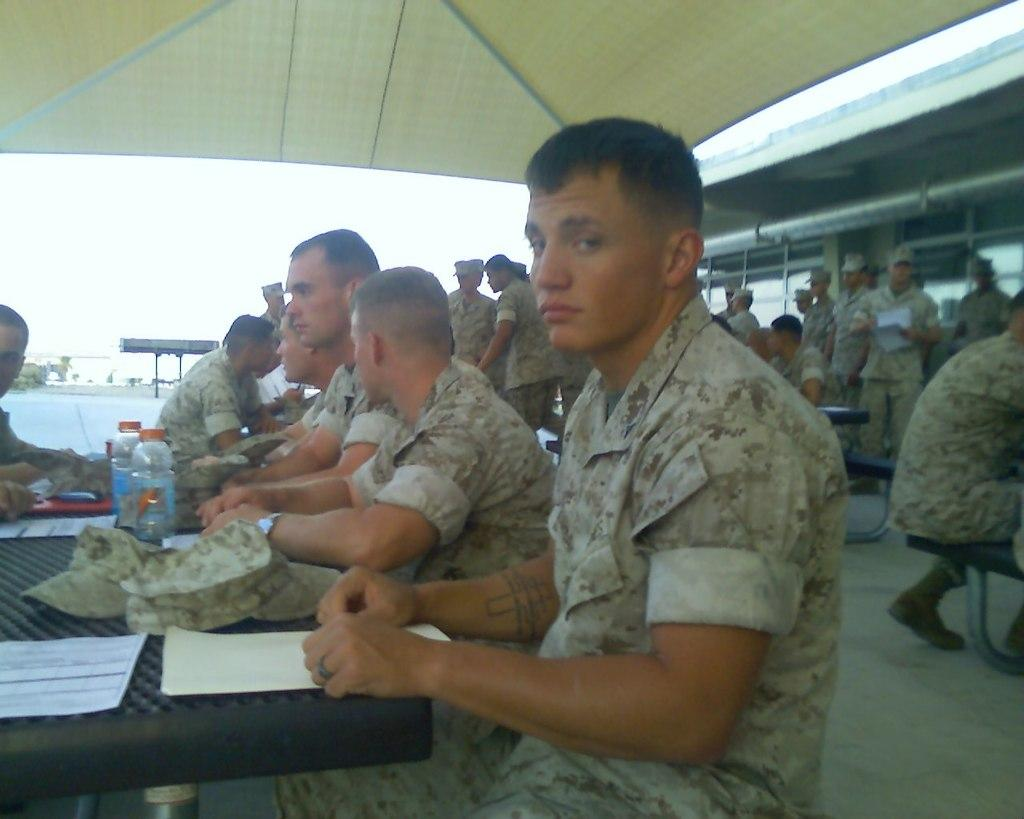Who or what can be seen in the image? There are people in the image. What type of furniture is present in the image? There are tables in the image. What items are related to writing or documentation in the image? There are papers in the image. What type of headwear is visible in the image? There are caps in the image. What type of containers are present in the image? There are bottles in the image. What type of structure is visible in the image? There is a shed in the image. What part of the ground is visible in the image? The floor is visible in the image. What other unspecified objects can be seen in the image? There are other unspecified objects in the image. What part of the natural environment is visible in the background of the image? The sky is visible in the background of the image. Can you see a scarf blowing in the wind at the seashore in the image? There is no seashore or scarf visible in the image. How does the way people interact with each other in the image affect the overall mood? The provided facts do not give any information about the interactions between people or the mood in the image. 